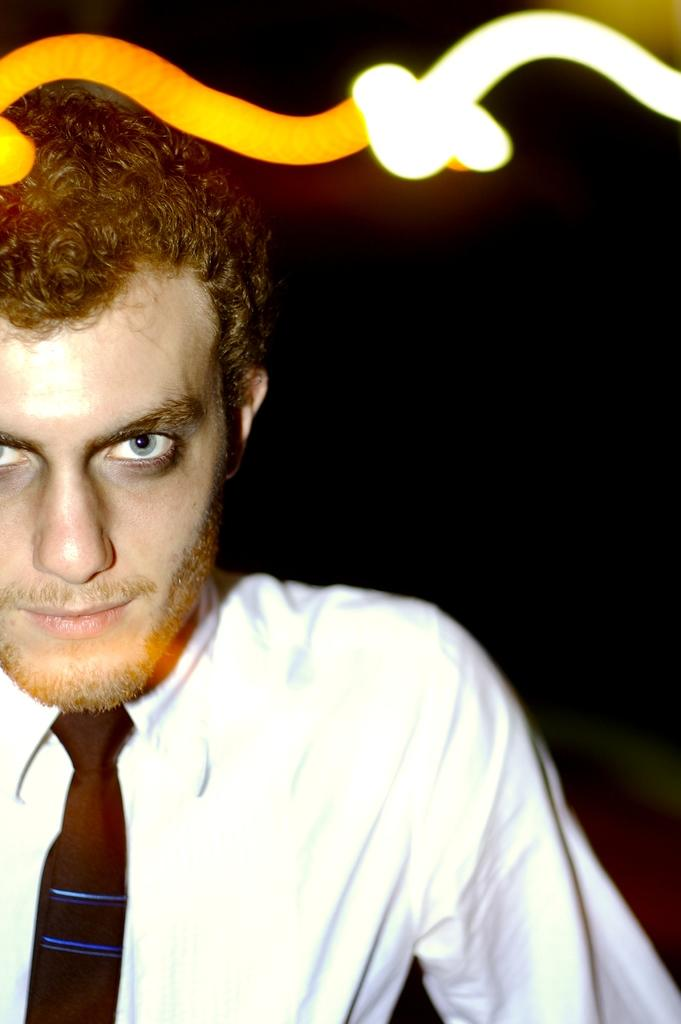Who is the main subject in the image? There is a man in the image. What is the man wearing on his upper body? The man is wearing a white shirt and a black tie. What is the man doing in the image? The man is looking into the camera. What can be seen behind the man in the image? There is a dark background in the image. What type of van can be seen in the background of the image? There is no van present in the image; it features a man wearing a white shirt and black tie, looking into the camera with a dark background. 